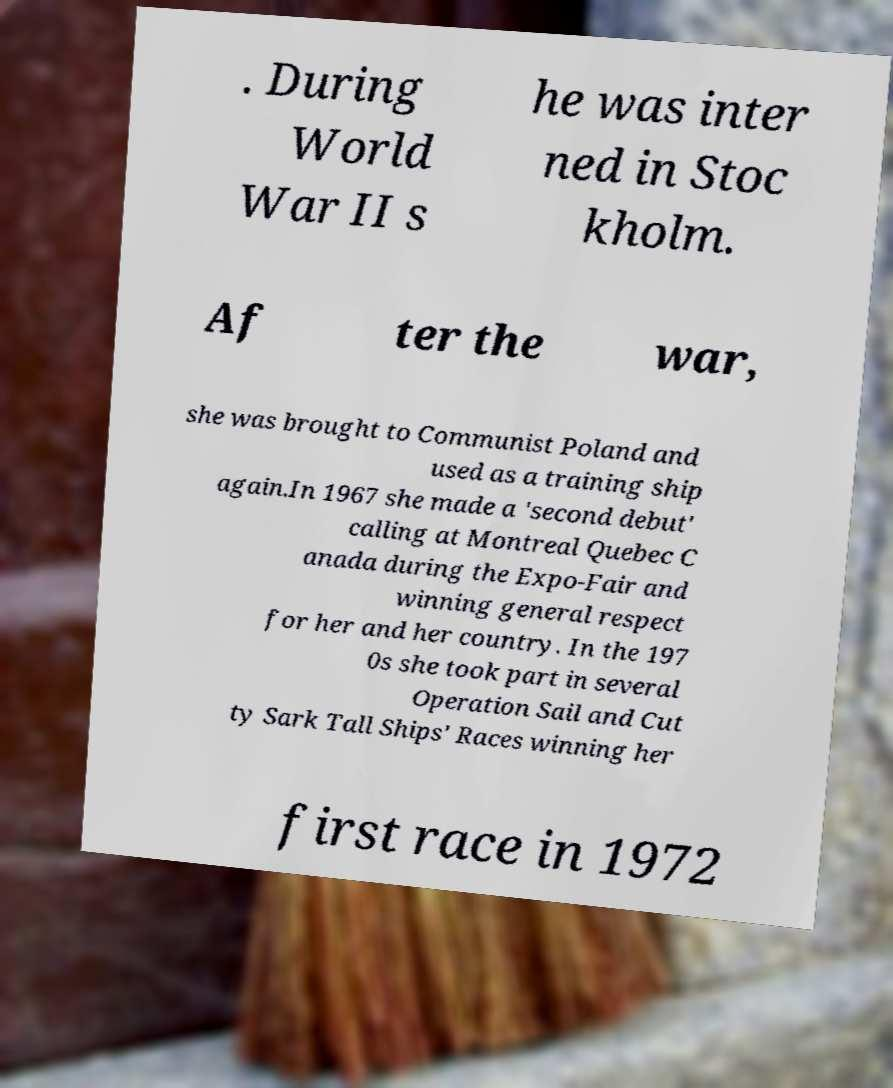What messages or text are displayed in this image? I need them in a readable, typed format. . During World War II s he was inter ned in Stoc kholm. Af ter the war, she was brought to Communist Poland and used as a training ship again.In 1967 she made a 'second debut' calling at Montreal Quebec C anada during the Expo-Fair and winning general respect for her and her country. In the 197 0s she took part in several Operation Sail and Cut ty Sark Tall Ships' Races winning her first race in 1972 